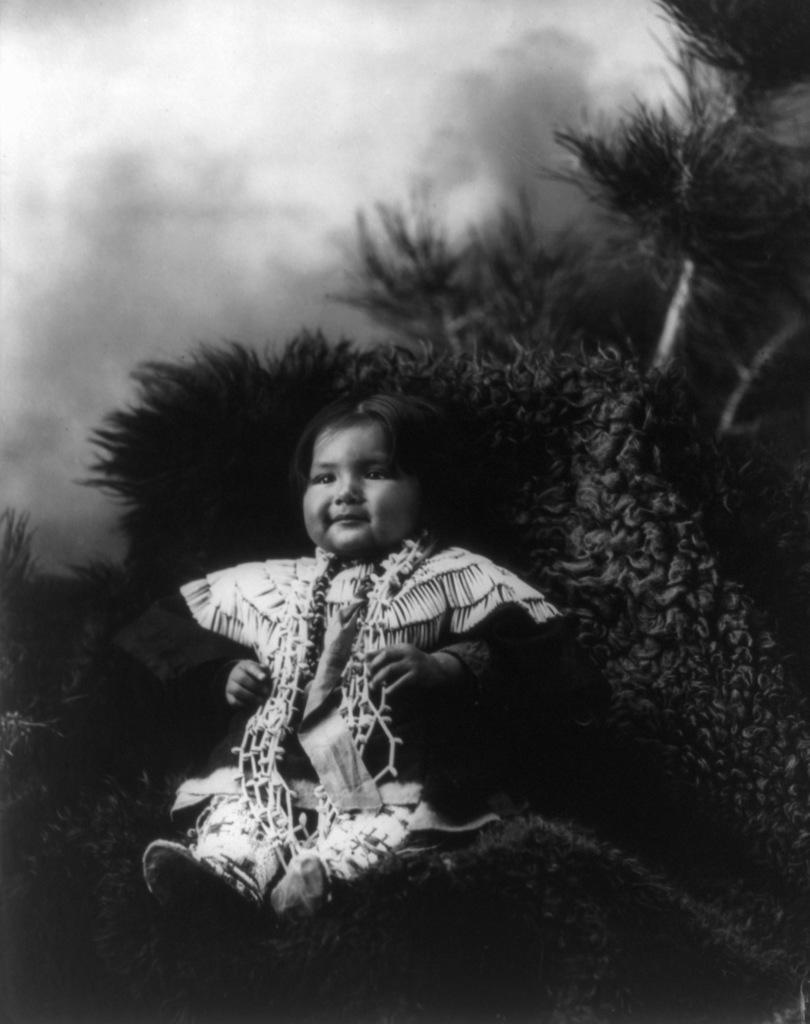What is the main subject of the image? There is a baby in the image. What is the baby doing in the image? The baby is smiling in the image. Where is the baby sitting in the image? The baby is sitting on a surface with grass in the image. What can be seen in the background of the image? There are trees, plants, and the sky visible in the background of the image. What type of furniture is the baby using to sit in the image? There is no furniture present in the image; the baby is sitting on a surface with grass. Who is the governor in the image? There is no mention of a governor in the image; it features a baby sitting on grass. 